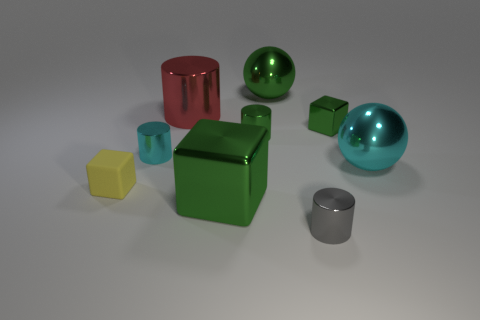Are there any other things that have the same material as the yellow block?
Offer a terse response. No. The yellow rubber object has what shape?
Ensure brevity in your answer.  Cube. What is the color of the small block that is on the right side of the gray thing?
Your answer should be very brief. Green. There is a cube that is on the left side of the cyan cylinder; is it the same size as the green sphere?
Provide a succinct answer. No. What size is the green object that is the same shape as the big red shiny thing?
Keep it short and to the point. Small. Is the shape of the tiny gray shiny thing the same as the yellow matte object?
Keep it short and to the point. No. Are there fewer cyan spheres that are in front of the small rubber block than rubber things right of the small green cylinder?
Ensure brevity in your answer.  No. What number of yellow objects are on the left side of the tiny yellow object?
Ensure brevity in your answer.  0. Is the shape of the large green metal object that is in front of the large cyan object the same as the tiny shiny thing that is in front of the tiny rubber block?
Offer a terse response. No. How many other things are the same color as the tiny metal block?
Your answer should be compact. 3. 